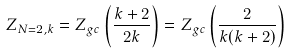<formula> <loc_0><loc_0><loc_500><loc_500>Z _ { N = 2 , k } = Z _ { g c } \left ( \frac { k + 2 } { 2 k } \right ) = Z _ { g c } \left ( \frac { 2 } { k ( k + 2 ) } \right )</formula> 